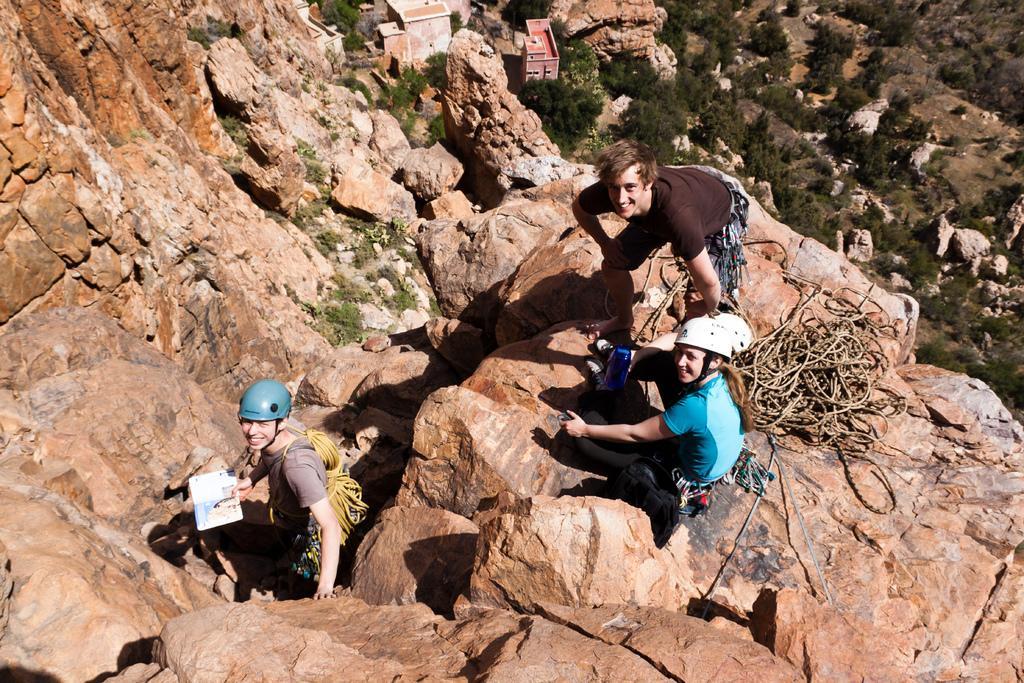How would you summarize this image in a sentence or two? In the image there are three people standing on the hill and looking upwards, there are some ropes behind them on the right side and behind the hill there are a lot of trees and some buildings downwards. 